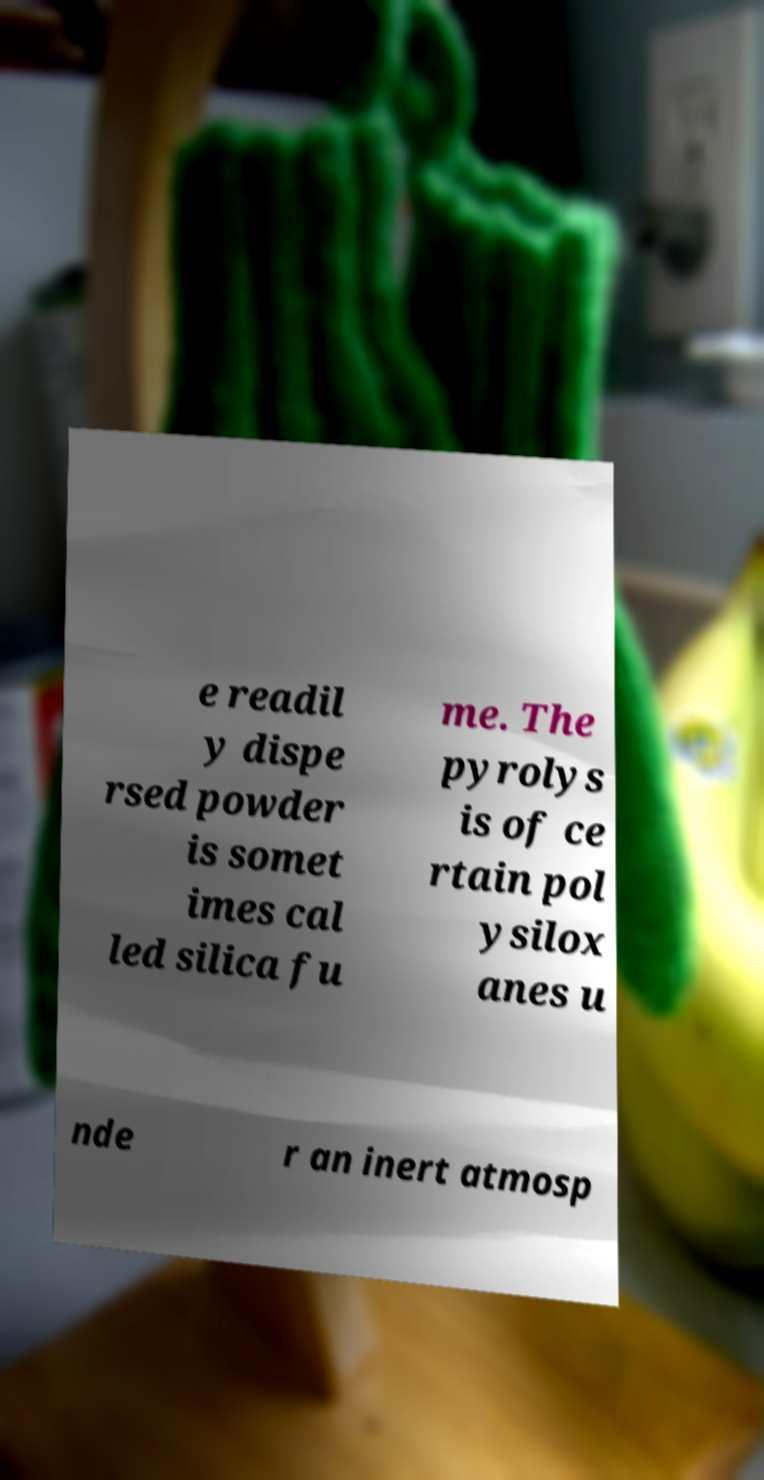Could you extract and type out the text from this image? e readil y dispe rsed powder is somet imes cal led silica fu me. The pyrolys is of ce rtain pol ysilox anes u nde r an inert atmosp 